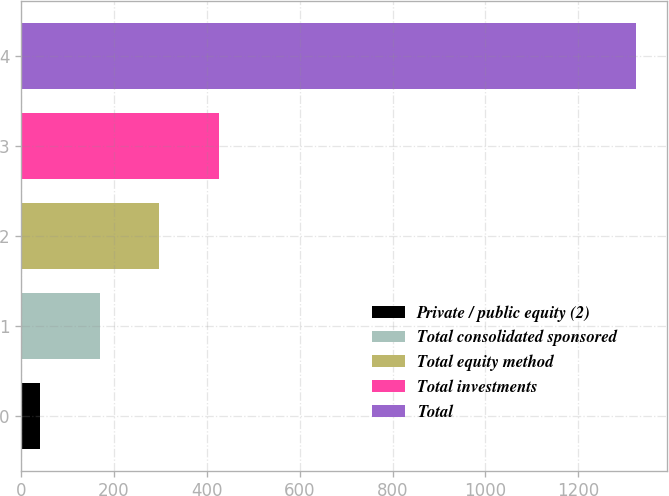Convert chart to OTSL. <chart><loc_0><loc_0><loc_500><loc_500><bar_chart><fcel>Private / public equity (2)<fcel>Total consolidated sponsored<fcel>Total equity method<fcel>Total investments<fcel>Total<nl><fcel>41<fcel>169.4<fcel>297.8<fcel>426.2<fcel>1325<nl></chart> 